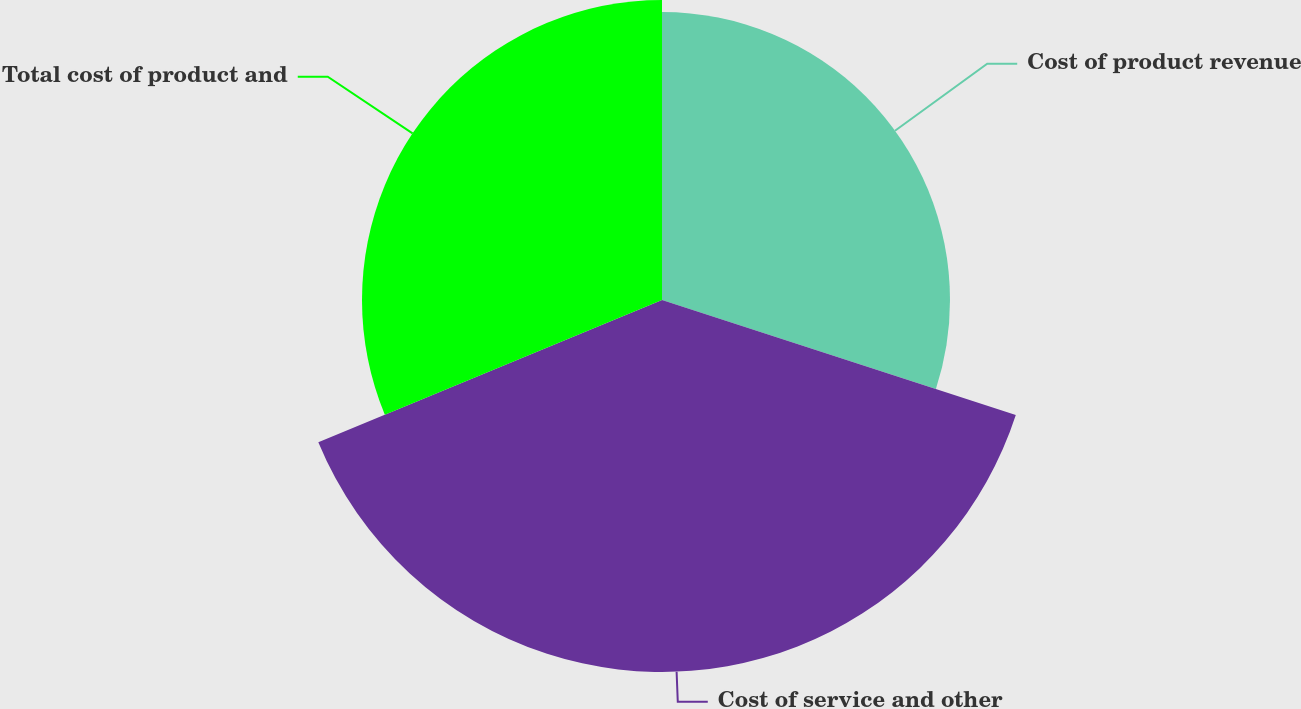Convert chart to OTSL. <chart><loc_0><loc_0><loc_500><loc_500><pie_chart><fcel>Cost of product revenue<fcel>Cost of service and other<fcel>Total cost of product and<nl><fcel>30.0%<fcel>38.75%<fcel>31.25%<nl></chart> 